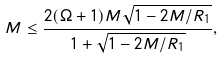Convert formula to latex. <formula><loc_0><loc_0><loc_500><loc_500>M \leq \frac { 2 ( \Omega + 1 ) M \sqrt { 1 - 2 M / R _ { 1 } } } { 1 + \sqrt { 1 - 2 M / R _ { 1 } } } ,</formula> 